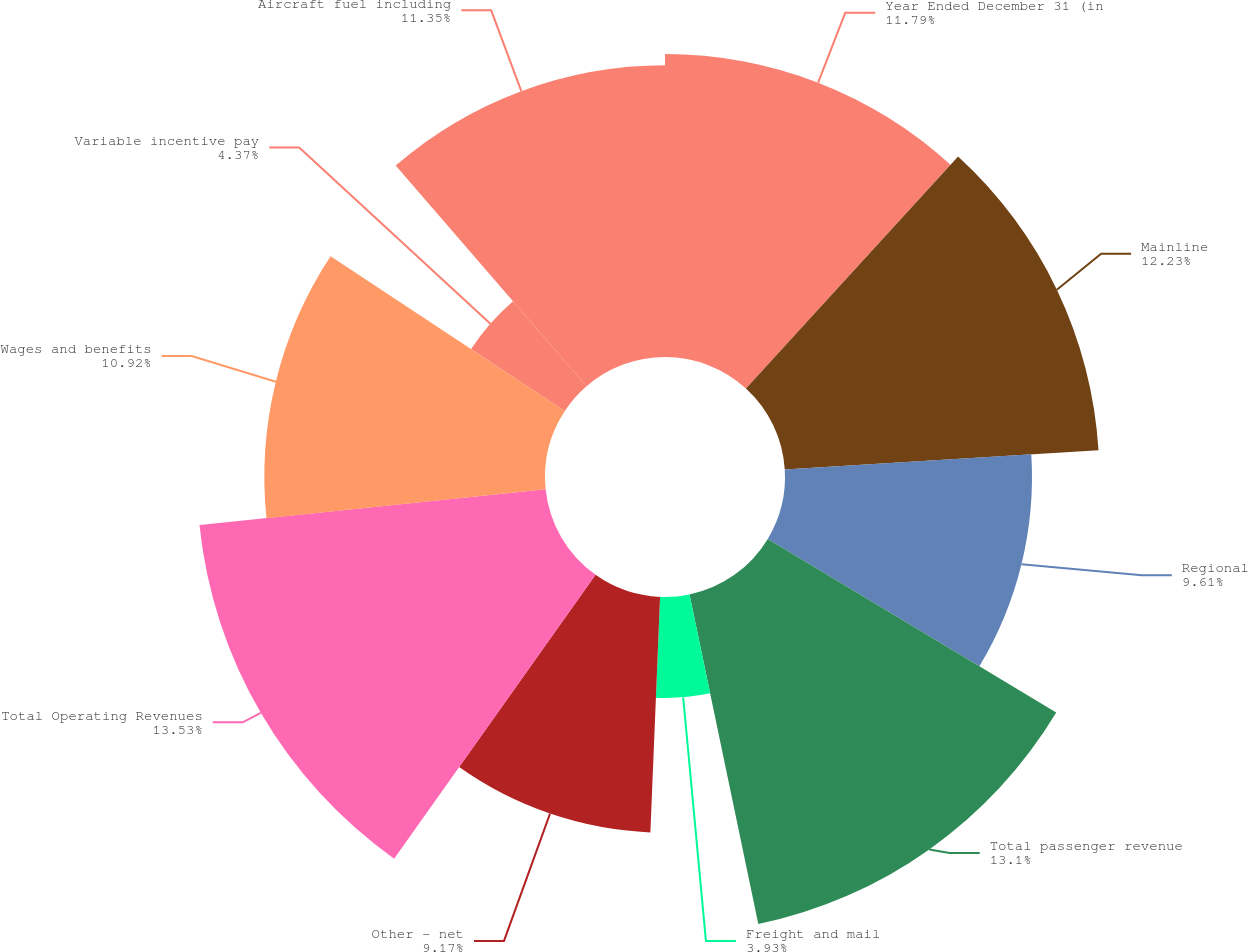Convert chart. <chart><loc_0><loc_0><loc_500><loc_500><pie_chart><fcel>Year Ended December 31 (in<fcel>Mainline<fcel>Regional<fcel>Total passenger revenue<fcel>Freight and mail<fcel>Other - net<fcel>Total Operating Revenues<fcel>Wages and benefits<fcel>Variable incentive pay<fcel>Aircraft fuel including<nl><fcel>11.79%<fcel>12.23%<fcel>9.61%<fcel>13.1%<fcel>3.93%<fcel>9.17%<fcel>13.54%<fcel>10.92%<fcel>4.37%<fcel>11.35%<nl></chart> 